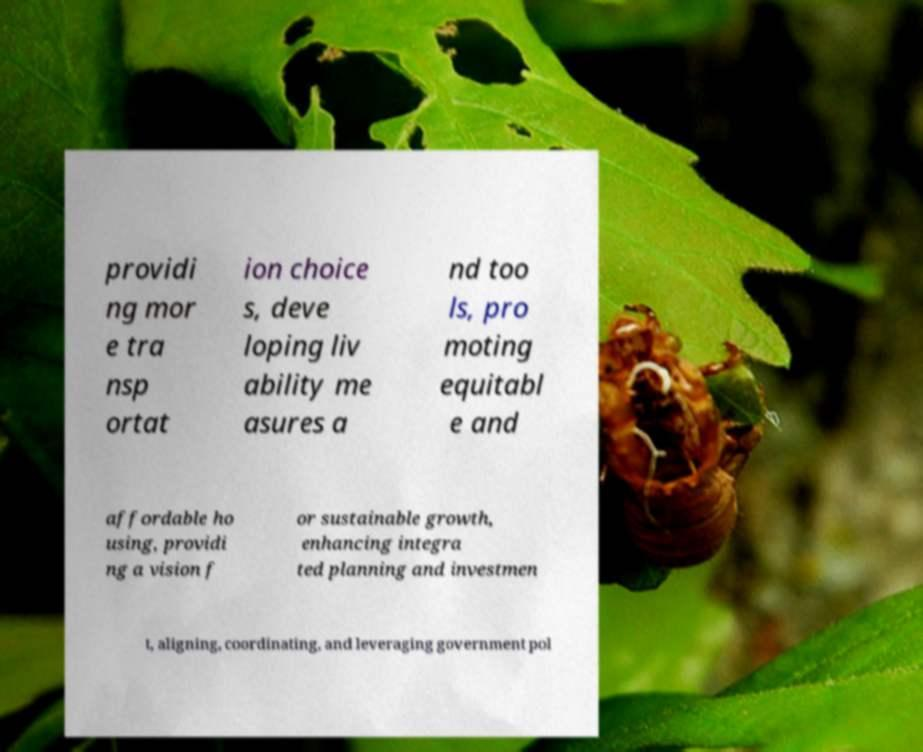Could you extract and type out the text from this image? providi ng mor e tra nsp ortat ion choice s, deve loping liv ability me asures a nd too ls, pro moting equitabl e and affordable ho using, providi ng a vision f or sustainable growth, enhancing integra ted planning and investmen t, aligning, coordinating, and leveraging government pol 